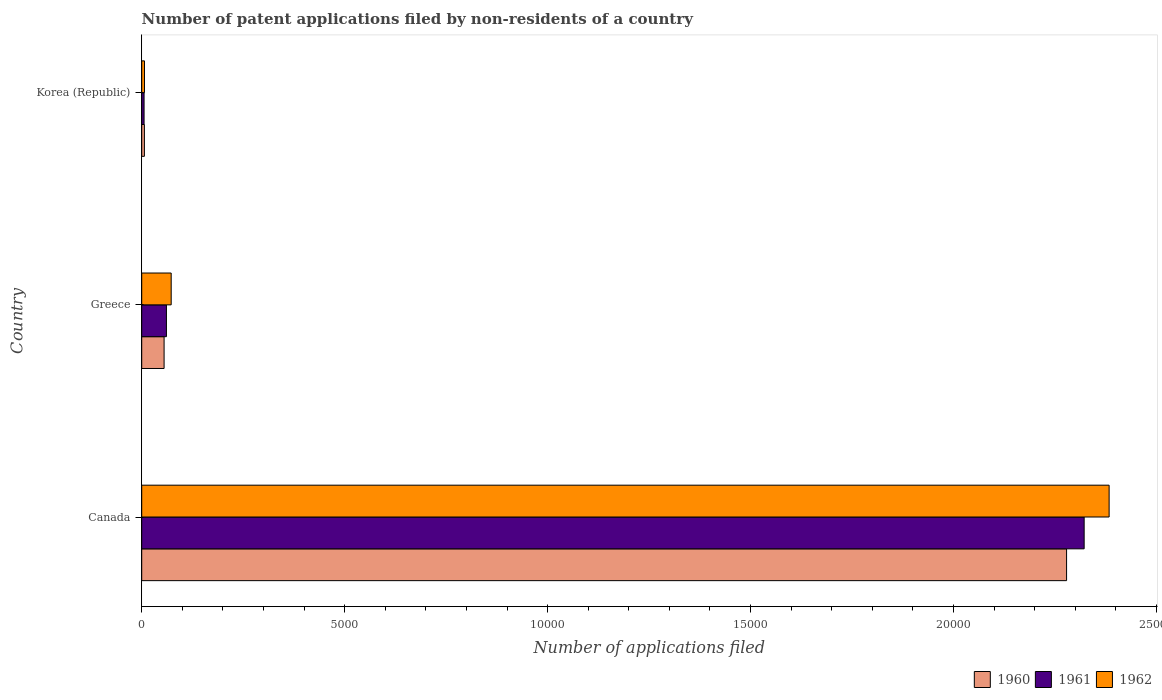How many different coloured bars are there?
Your response must be concise. 3. How many groups of bars are there?
Provide a succinct answer. 3. Are the number of bars on each tick of the Y-axis equal?
Your response must be concise. Yes. How many bars are there on the 1st tick from the bottom?
Provide a succinct answer. 3. In how many cases, is the number of bars for a given country not equal to the number of legend labels?
Your response must be concise. 0. What is the number of applications filed in 1962 in Canada?
Provide a short and direct response. 2.38e+04. Across all countries, what is the maximum number of applications filed in 1961?
Ensure brevity in your answer.  2.32e+04. Across all countries, what is the minimum number of applications filed in 1962?
Ensure brevity in your answer.  68. In which country was the number of applications filed in 1961 minimum?
Your answer should be compact. Korea (Republic). What is the total number of applications filed in 1961 in the graph?
Keep it short and to the point. 2.39e+04. What is the difference between the number of applications filed in 1961 in Greece and that in Korea (Republic)?
Keep it short and to the point. 551. What is the difference between the number of applications filed in 1962 in Greece and the number of applications filed in 1961 in Korea (Republic)?
Provide a short and direct response. 668. What is the average number of applications filed in 1960 per country?
Ensure brevity in your answer.  7801. What is the difference between the number of applications filed in 1962 and number of applications filed in 1961 in Korea (Republic)?
Give a very brief answer. 10. In how many countries, is the number of applications filed in 1962 greater than 5000 ?
Make the answer very short. 1. What is the ratio of the number of applications filed in 1960 in Canada to that in Greece?
Ensure brevity in your answer.  41.35. Is the number of applications filed in 1960 in Canada less than that in Korea (Republic)?
Your answer should be compact. No. What is the difference between the highest and the second highest number of applications filed in 1961?
Keep it short and to the point. 2.26e+04. What is the difference between the highest and the lowest number of applications filed in 1962?
Ensure brevity in your answer.  2.38e+04. What does the 2nd bar from the top in Canada represents?
Offer a terse response. 1961. Is it the case that in every country, the sum of the number of applications filed in 1961 and number of applications filed in 1962 is greater than the number of applications filed in 1960?
Provide a succinct answer. Yes. How many bars are there?
Make the answer very short. 9. What is the difference between two consecutive major ticks on the X-axis?
Your answer should be very brief. 5000. Are the values on the major ticks of X-axis written in scientific E-notation?
Provide a short and direct response. No. Does the graph contain grids?
Ensure brevity in your answer.  No. How many legend labels are there?
Provide a short and direct response. 3. How are the legend labels stacked?
Make the answer very short. Horizontal. What is the title of the graph?
Keep it short and to the point. Number of patent applications filed by non-residents of a country. What is the label or title of the X-axis?
Provide a short and direct response. Number of applications filed. What is the Number of applications filed in 1960 in Canada?
Your answer should be very brief. 2.28e+04. What is the Number of applications filed in 1961 in Canada?
Keep it short and to the point. 2.32e+04. What is the Number of applications filed in 1962 in Canada?
Your answer should be compact. 2.38e+04. What is the Number of applications filed in 1960 in Greece?
Your answer should be very brief. 551. What is the Number of applications filed of 1961 in Greece?
Your answer should be very brief. 609. What is the Number of applications filed of 1962 in Greece?
Ensure brevity in your answer.  726. What is the Number of applications filed of 1960 in Korea (Republic)?
Your answer should be very brief. 66. Across all countries, what is the maximum Number of applications filed of 1960?
Make the answer very short. 2.28e+04. Across all countries, what is the maximum Number of applications filed in 1961?
Provide a succinct answer. 2.32e+04. Across all countries, what is the maximum Number of applications filed in 1962?
Offer a very short reply. 2.38e+04. Across all countries, what is the minimum Number of applications filed of 1961?
Give a very brief answer. 58. Across all countries, what is the minimum Number of applications filed in 1962?
Offer a very short reply. 68. What is the total Number of applications filed in 1960 in the graph?
Ensure brevity in your answer.  2.34e+04. What is the total Number of applications filed in 1961 in the graph?
Ensure brevity in your answer.  2.39e+04. What is the total Number of applications filed in 1962 in the graph?
Offer a terse response. 2.46e+04. What is the difference between the Number of applications filed in 1960 in Canada and that in Greece?
Your response must be concise. 2.22e+04. What is the difference between the Number of applications filed in 1961 in Canada and that in Greece?
Ensure brevity in your answer.  2.26e+04. What is the difference between the Number of applications filed in 1962 in Canada and that in Greece?
Offer a very short reply. 2.31e+04. What is the difference between the Number of applications filed of 1960 in Canada and that in Korea (Republic)?
Ensure brevity in your answer.  2.27e+04. What is the difference between the Number of applications filed of 1961 in Canada and that in Korea (Republic)?
Keep it short and to the point. 2.32e+04. What is the difference between the Number of applications filed in 1962 in Canada and that in Korea (Republic)?
Your answer should be very brief. 2.38e+04. What is the difference between the Number of applications filed of 1960 in Greece and that in Korea (Republic)?
Ensure brevity in your answer.  485. What is the difference between the Number of applications filed of 1961 in Greece and that in Korea (Republic)?
Your answer should be compact. 551. What is the difference between the Number of applications filed in 1962 in Greece and that in Korea (Republic)?
Offer a very short reply. 658. What is the difference between the Number of applications filed in 1960 in Canada and the Number of applications filed in 1961 in Greece?
Your response must be concise. 2.22e+04. What is the difference between the Number of applications filed in 1960 in Canada and the Number of applications filed in 1962 in Greece?
Keep it short and to the point. 2.21e+04. What is the difference between the Number of applications filed of 1961 in Canada and the Number of applications filed of 1962 in Greece?
Offer a terse response. 2.25e+04. What is the difference between the Number of applications filed in 1960 in Canada and the Number of applications filed in 1961 in Korea (Republic)?
Ensure brevity in your answer.  2.27e+04. What is the difference between the Number of applications filed in 1960 in Canada and the Number of applications filed in 1962 in Korea (Republic)?
Provide a succinct answer. 2.27e+04. What is the difference between the Number of applications filed of 1961 in Canada and the Number of applications filed of 1962 in Korea (Republic)?
Your response must be concise. 2.32e+04. What is the difference between the Number of applications filed of 1960 in Greece and the Number of applications filed of 1961 in Korea (Republic)?
Your response must be concise. 493. What is the difference between the Number of applications filed in 1960 in Greece and the Number of applications filed in 1962 in Korea (Republic)?
Provide a short and direct response. 483. What is the difference between the Number of applications filed in 1961 in Greece and the Number of applications filed in 1962 in Korea (Republic)?
Offer a terse response. 541. What is the average Number of applications filed of 1960 per country?
Ensure brevity in your answer.  7801. What is the average Number of applications filed of 1961 per country?
Provide a succinct answer. 7962. What is the average Number of applications filed in 1962 per country?
Ensure brevity in your answer.  8209.33. What is the difference between the Number of applications filed of 1960 and Number of applications filed of 1961 in Canada?
Give a very brief answer. -433. What is the difference between the Number of applications filed of 1960 and Number of applications filed of 1962 in Canada?
Provide a succinct answer. -1048. What is the difference between the Number of applications filed of 1961 and Number of applications filed of 1962 in Canada?
Ensure brevity in your answer.  -615. What is the difference between the Number of applications filed of 1960 and Number of applications filed of 1961 in Greece?
Provide a succinct answer. -58. What is the difference between the Number of applications filed of 1960 and Number of applications filed of 1962 in Greece?
Your answer should be compact. -175. What is the difference between the Number of applications filed in 1961 and Number of applications filed in 1962 in Greece?
Provide a short and direct response. -117. What is the difference between the Number of applications filed in 1960 and Number of applications filed in 1961 in Korea (Republic)?
Give a very brief answer. 8. What is the difference between the Number of applications filed in 1960 and Number of applications filed in 1962 in Korea (Republic)?
Offer a very short reply. -2. What is the difference between the Number of applications filed in 1961 and Number of applications filed in 1962 in Korea (Republic)?
Your response must be concise. -10. What is the ratio of the Number of applications filed of 1960 in Canada to that in Greece?
Your answer should be very brief. 41.35. What is the ratio of the Number of applications filed of 1961 in Canada to that in Greece?
Provide a short and direct response. 38.13. What is the ratio of the Number of applications filed of 1962 in Canada to that in Greece?
Your answer should be very brief. 32.83. What is the ratio of the Number of applications filed of 1960 in Canada to that in Korea (Republic)?
Keep it short and to the point. 345.24. What is the ratio of the Number of applications filed of 1961 in Canada to that in Korea (Republic)?
Provide a succinct answer. 400.33. What is the ratio of the Number of applications filed of 1962 in Canada to that in Korea (Republic)?
Offer a very short reply. 350.5. What is the ratio of the Number of applications filed in 1960 in Greece to that in Korea (Republic)?
Offer a very short reply. 8.35. What is the ratio of the Number of applications filed in 1962 in Greece to that in Korea (Republic)?
Your answer should be very brief. 10.68. What is the difference between the highest and the second highest Number of applications filed of 1960?
Keep it short and to the point. 2.22e+04. What is the difference between the highest and the second highest Number of applications filed in 1961?
Keep it short and to the point. 2.26e+04. What is the difference between the highest and the second highest Number of applications filed of 1962?
Give a very brief answer. 2.31e+04. What is the difference between the highest and the lowest Number of applications filed in 1960?
Ensure brevity in your answer.  2.27e+04. What is the difference between the highest and the lowest Number of applications filed of 1961?
Your answer should be very brief. 2.32e+04. What is the difference between the highest and the lowest Number of applications filed of 1962?
Provide a succinct answer. 2.38e+04. 